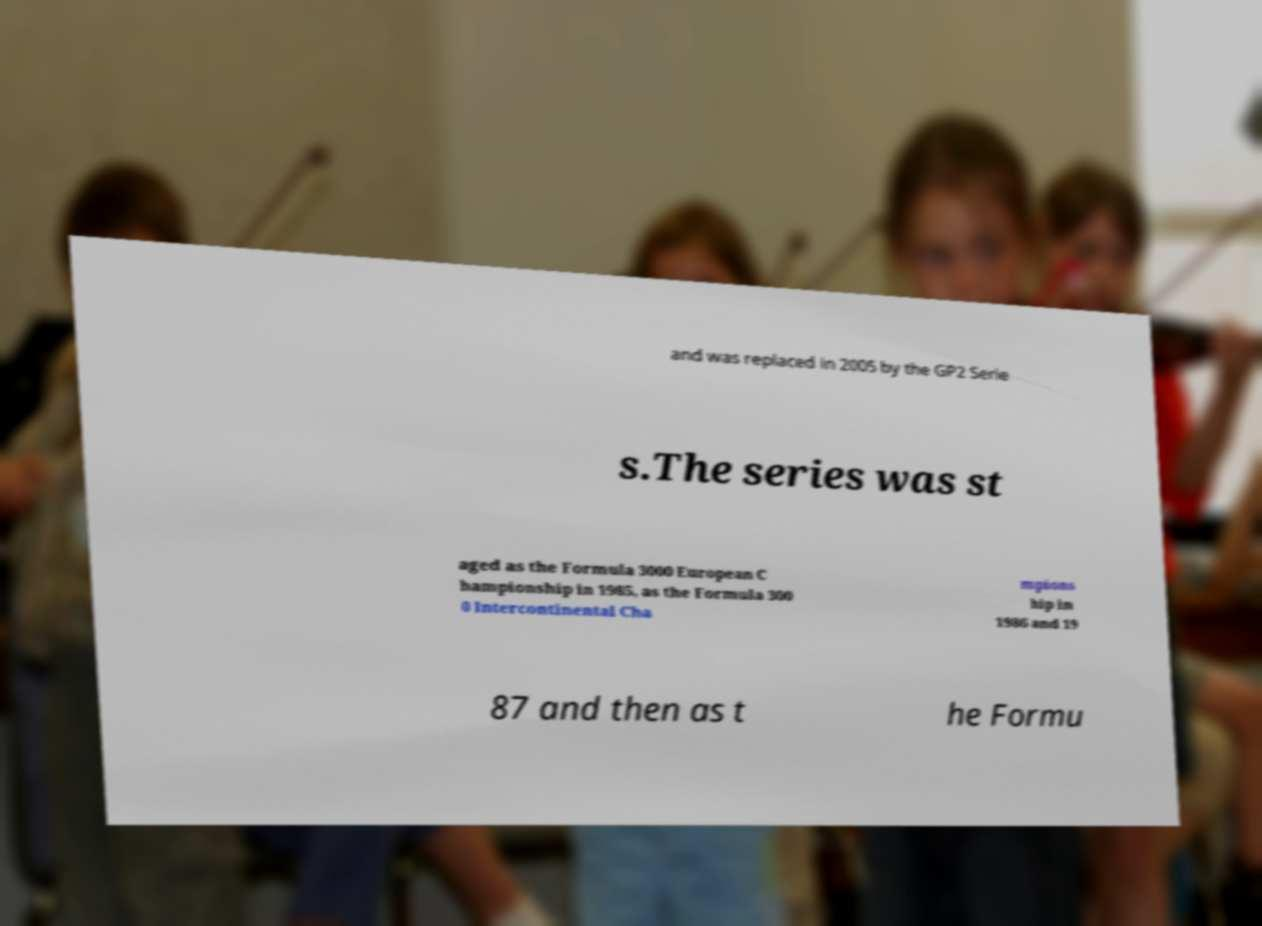Can you read and provide the text displayed in the image?This photo seems to have some interesting text. Can you extract and type it out for me? and was replaced in 2005 by the GP2 Serie s.The series was st aged as the Formula 3000 European C hampionship in 1985, as the Formula 300 0 Intercontinental Cha mpions hip in 1986 and 19 87 and then as t he Formu 